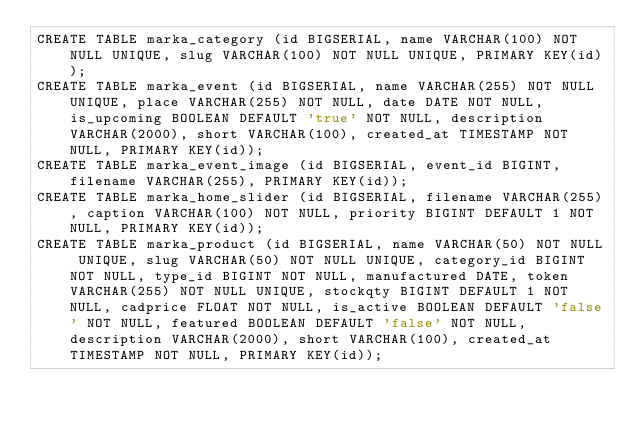<code> <loc_0><loc_0><loc_500><loc_500><_SQL_>CREATE TABLE marka_category (id BIGSERIAL, name VARCHAR(100) NOT NULL UNIQUE, slug VARCHAR(100) NOT NULL UNIQUE, PRIMARY KEY(id));
CREATE TABLE marka_event (id BIGSERIAL, name VARCHAR(255) NOT NULL UNIQUE, place VARCHAR(255) NOT NULL, date DATE NOT NULL, is_upcoming BOOLEAN DEFAULT 'true' NOT NULL, description VARCHAR(2000), short VARCHAR(100), created_at TIMESTAMP NOT NULL, PRIMARY KEY(id));
CREATE TABLE marka_event_image (id BIGSERIAL, event_id BIGINT, filename VARCHAR(255), PRIMARY KEY(id));
CREATE TABLE marka_home_slider (id BIGSERIAL, filename VARCHAR(255), caption VARCHAR(100) NOT NULL, priority BIGINT DEFAULT 1 NOT NULL, PRIMARY KEY(id));
CREATE TABLE marka_product (id BIGSERIAL, name VARCHAR(50) NOT NULL UNIQUE, slug VARCHAR(50) NOT NULL UNIQUE, category_id BIGINT NOT NULL, type_id BIGINT NOT NULL, manufactured DATE, token VARCHAR(255) NOT NULL UNIQUE, stockqty BIGINT DEFAULT 1 NOT NULL, cadprice FLOAT NOT NULL, is_active BOOLEAN DEFAULT 'false' NOT NULL, featured BOOLEAN DEFAULT 'false' NOT NULL, description VARCHAR(2000), short VARCHAR(100), created_at TIMESTAMP NOT NULL, PRIMARY KEY(id));</code> 